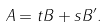Convert formula to latex. <formula><loc_0><loc_0><loc_500><loc_500>A = t B + s B ^ { \prime } .</formula> 